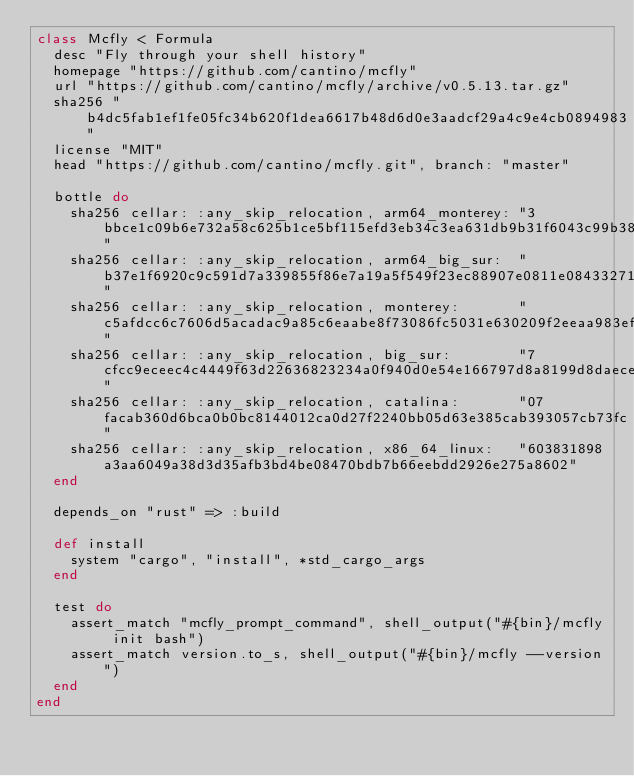Convert code to text. <code><loc_0><loc_0><loc_500><loc_500><_Ruby_>class Mcfly < Formula
  desc "Fly through your shell history"
  homepage "https://github.com/cantino/mcfly"
  url "https://github.com/cantino/mcfly/archive/v0.5.13.tar.gz"
  sha256 "b4dc5fab1ef1fe05fc34b620f1dea6617b48d6d0e3aadcf29a4c9e4cb0894983"
  license "MIT"
  head "https://github.com/cantino/mcfly.git", branch: "master"

  bottle do
    sha256 cellar: :any_skip_relocation, arm64_monterey: "3bbce1c09b6e732a58c625b1ce5bf115efd3eb34c3ea631db9b31f6043c99b38"
    sha256 cellar: :any_skip_relocation, arm64_big_sur:  "b37e1f6920c9c591d7a339855f86e7a19a5f549f23ec88907e0811e084332717"
    sha256 cellar: :any_skip_relocation, monterey:       "c5afdcc6c7606d5acadac9a85c6eaabe8f73086fc5031e630209f2eeaa983ef0"
    sha256 cellar: :any_skip_relocation, big_sur:        "7cfcc9eceec4c4449f63d22636823234a0f940d0e54e166797d8a8199d8daece"
    sha256 cellar: :any_skip_relocation, catalina:       "07facab360d6bca0b0bc8144012ca0d27f2240bb05d63e385cab393057cb73fc"
    sha256 cellar: :any_skip_relocation, x86_64_linux:   "603831898a3aa6049a38d3d35afb3bd4be08470bdb7b66eebdd2926e275a8602"
  end

  depends_on "rust" => :build

  def install
    system "cargo", "install", *std_cargo_args
  end

  test do
    assert_match "mcfly_prompt_command", shell_output("#{bin}/mcfly init bash")
    assert_match version.to_s, shell_output("#{bin}/mcfly --version")
  end
end
</code> 